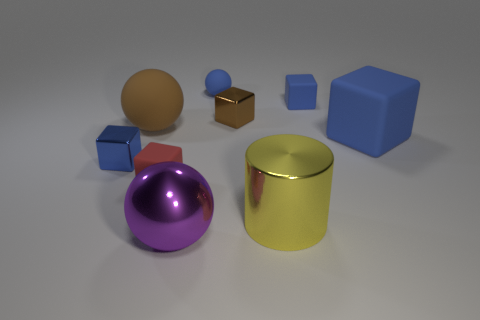What material is the yellow cylinder that is the same size as the purple thing?
Give a very brief answer. Metal. What size is the matte block behind the large brown rubber thing?
Make the answer very short. Small. Does the blue matte object left of the large yellow cylinder have the same size as the blue cube that is left of the large purple sphere?
Keep it short and to the point. Yes. What number of tiny cylinders are the same material as the big brown ball?
Offer a terse response. 0. What color is the large metal cylinder?
Your answer should be very brief. Yellow. Are there any big matte balls to the right of the large yellow metal cylinder?
Your answer should be compact. No. Is the large matte sphere the same color as the metallic sphere?
Provide a short and direct response. No. How many big shiny objects are the same color as the cylinder?
Your response must be concise. 0. What is the size of the shiny thing behind the blue block left of the large purple metallic sphere?
Your answer should be very brief. Small. There is a red thing; what shape is it?
Give a very brief answer. Cube. 